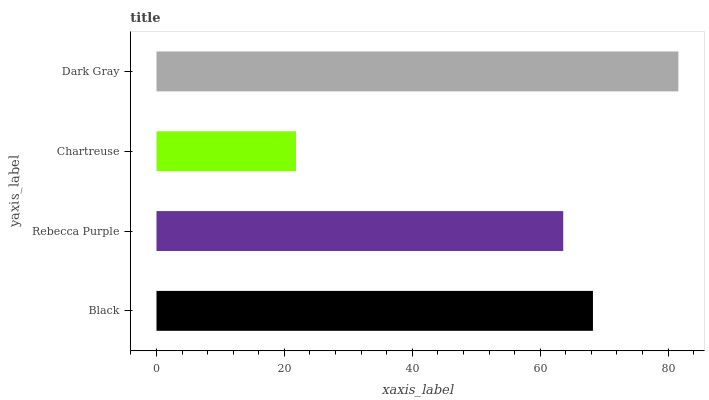Is Chartreuse the minimum?
Answer yes or no. Yes. Is Dark Gray the maximum?
Answer yes or no. Yes. Is Rebecca Purple the minimum?
Answer yes or no. No. Is Rebecca Purple the maximum?
Answer yes or no. No. Is Black greater than Rebecca Purple?
Answer yes or no. Yes. Is Rebecca Purple less than Black?
Answer yes or no. Yes. Is Rebecca Purple greater than Black?
Answer yes or no. No. Is Black less than Rebecca Purple?
Answer yes or no. No. Is Black the high median?
Answer yes or no. Yes. Is Rebecca Purple the low median?
Answer yes or no. Yes. Is Rebecca Purple the high median?
Answer yes or no. No. Is Dark Gray the low median?
Answer yes or no. No. 